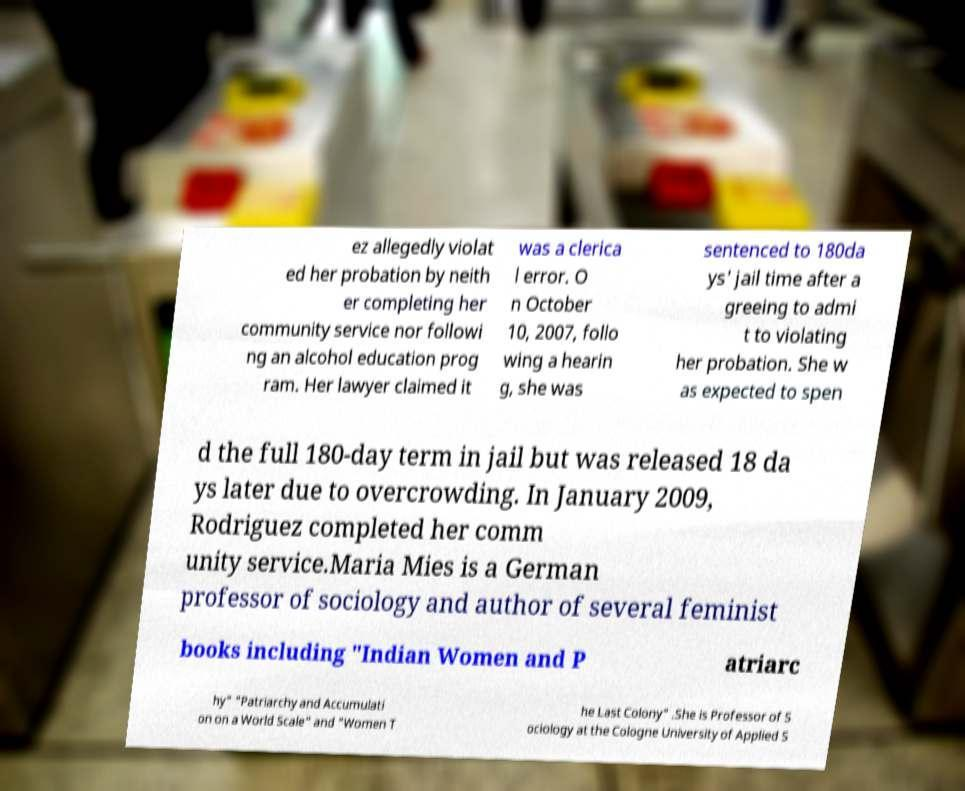Could you assist in decoding the text presented in this image and type it out clearly? ez allegedly violat ed her probation by neith er completing her community service nor followi ng an alcohol education prog ram. Her lawyer claimed it was a clerica l error. O n October 10, 2007, follo wing a hearin g, she was sentenced to 180da ys' jail time after a greeing to admi t to violating her probation. She w as expected to spen d the full 180-day term in jail but was released 18 da ys later due to overcrowding. In January 2009, Rodriguez completed her comm unity service.Maria Mies is a German professor of sociology and author of several feminist books including "Indian Women and P atriarc hy" "Patriarchy and Accumulati on on a World Scale" and "Women T he Last Colony" .She is Professor of S ociology at the Cologne University of Applied S 